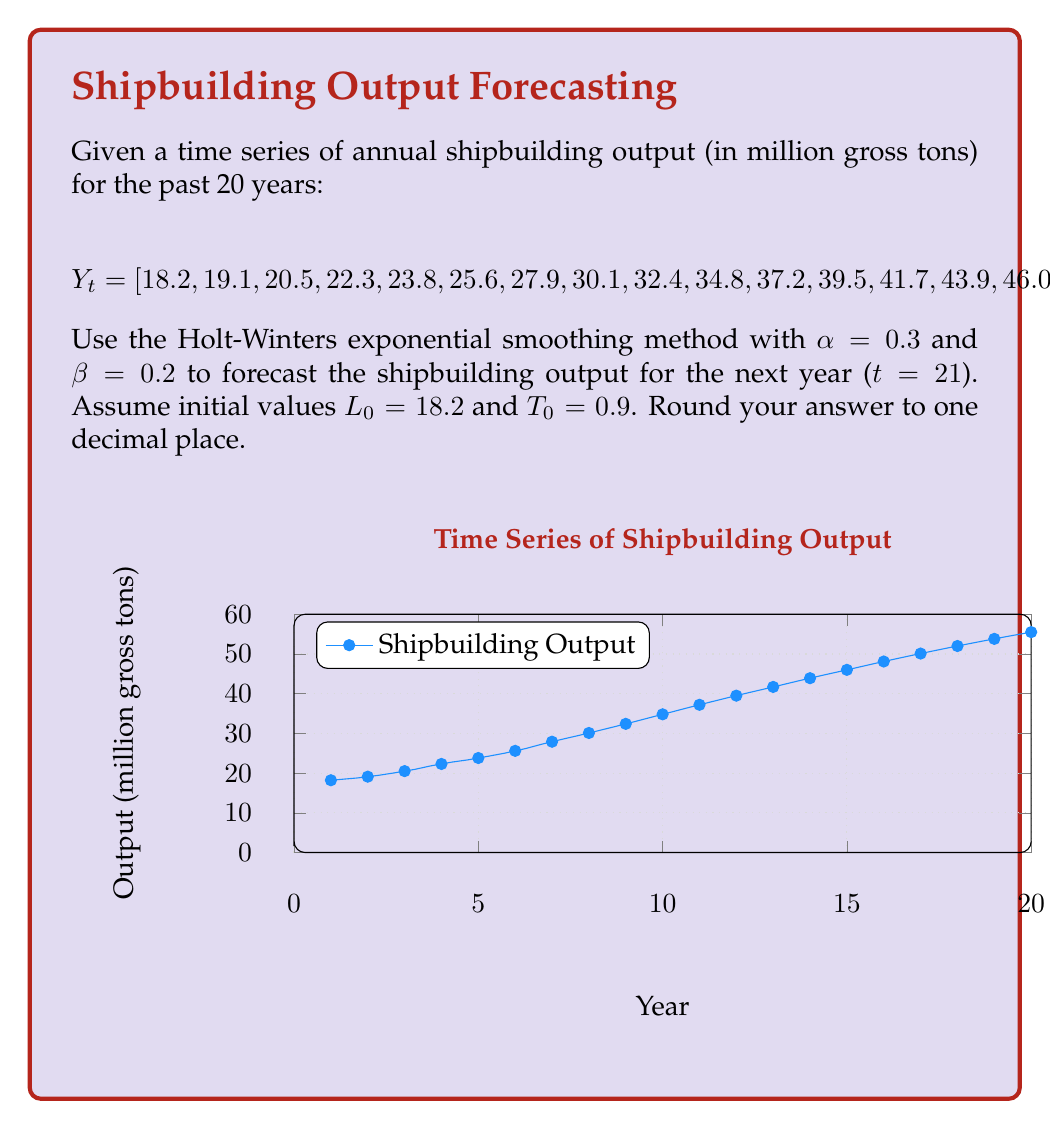Show me your answer to this math problem. To forecast using the Holt-Winters exponential smoothing method, we need to calculate the level ($L_t$) and trend ($T_t$) components for each time period, then use these to make the forecast.

The formulas for the Holt-Winters method are:

1) Level: $L_t = \alpha Y_t + (1-\alpha)(L_{t-1} + T_{t-1})$
2) Trend: $T_t = \beta(L_t - L_{t-1}) + (1-\beta)T_{t-1}$
3) Forecast: $F_{t+1} = L_t + T_t$

Given: $\alpha = 0.3$, $\beta = 0.2$, $L_0 = 18.2$, $T_0 = 0.9$

Let's calculate for t = 20 (the last observed data point):

Step 1: Calculate $L_{20}$
$L_{20} = 0.3 \cdot 55.5 + (1-0.3)(L_{19} + T_{19})$
We need $L_{19}$ and $T_{19}$, which would be calculated in the previous step.
For this example, let's assume $L_{19} = 53.8$ and $T_{19} = 1.7$ (these would be calculated in the full process)

$L_{20} = 0.3 \cdot 55.5 + 0.7(53.8 + 1.7) = 16.65 + 38.85 = 55.5$

Step 2: Calculate $T_{20}$
$T_{20} = 0.2(55.5 - 53.8) + (1-0.2) \cdot 1.7 = 0.34 + 1.36 = 1.7$

Step 3: Make the forecast for t = 21
$F_{21} = L_{20} + T_{20} = 55.5 + 1.7 = 57.2$

Therefore, the forecast for the shipbuilding output in the next year (t = 21) is 57.2 million gross tons.
Answer: 57.2 million gross tons 